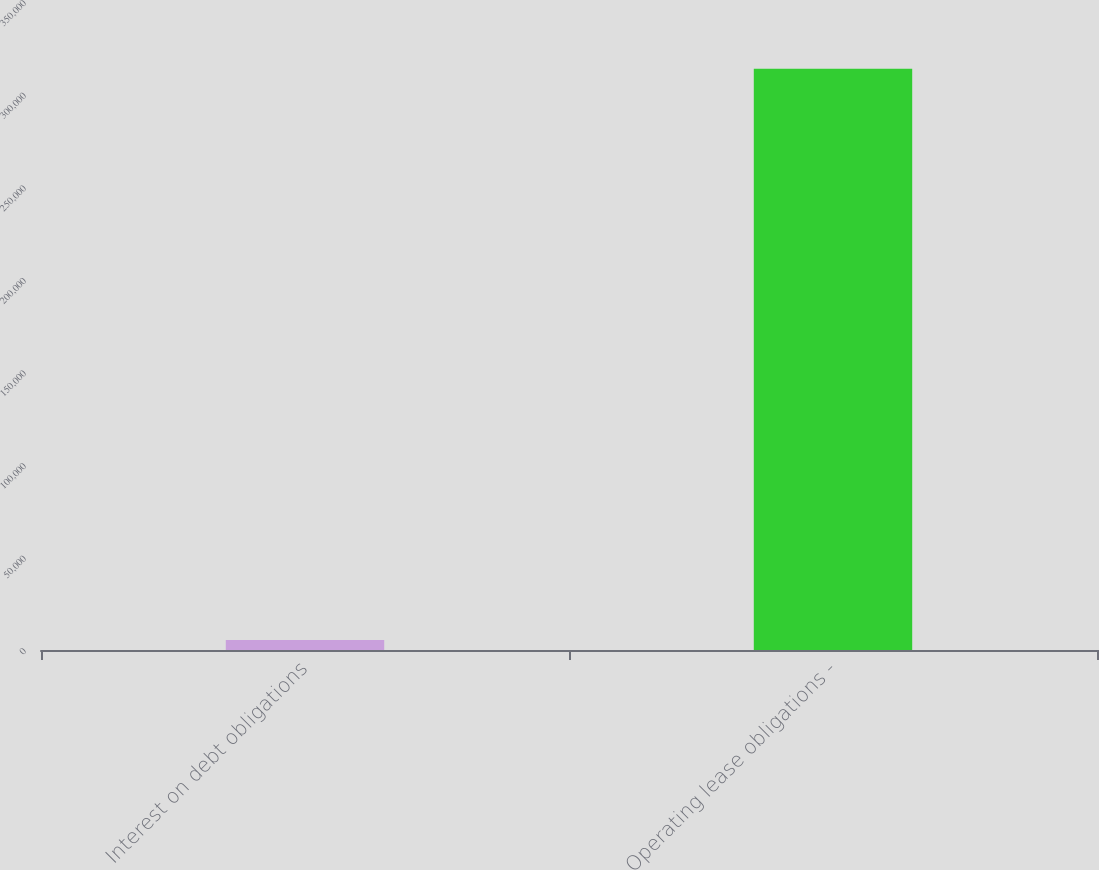Convert chart. <chart><loc_0><loc_0><loc_500><loc_500><bar_chart><fcel>Interest on debt obligations<fcel>Operating lease obligations -<nl><fcel>5385<fcel>313918<nl></chart> 